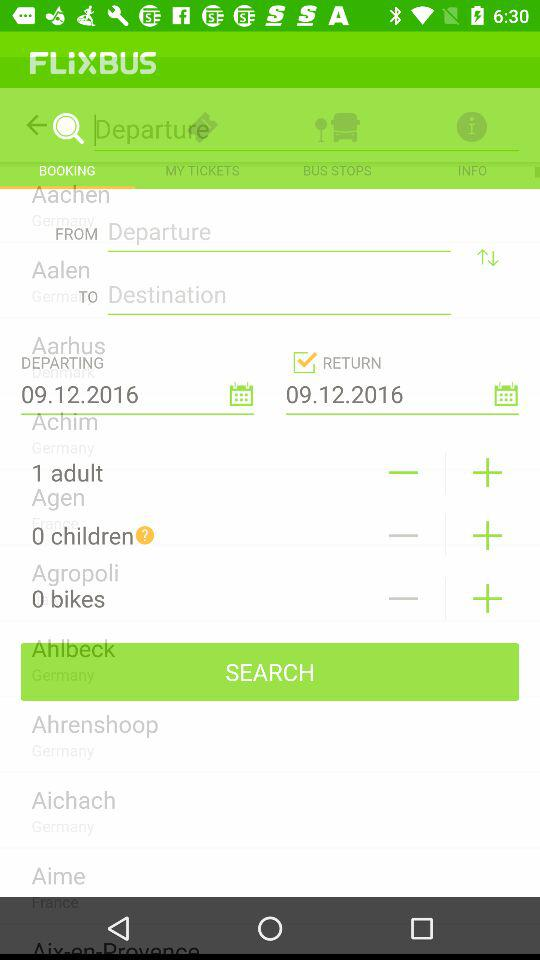How many more people are going than bikes?
Answer the question using a single word or phrase. 1 